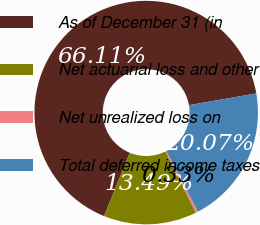Convert chart. <chart><loc_0><loc_0><loc_500><loc_500><pie_chart><fcel>As of December 31 (in<fcel>Net actuarial loss and other<fcel>Net unrealized loss on<fcel>Total deferred income taxes<nl><fcel>66.11%<fcel>13.49%<fcel>0.33%<fcel>20.07%<nl></chart> 